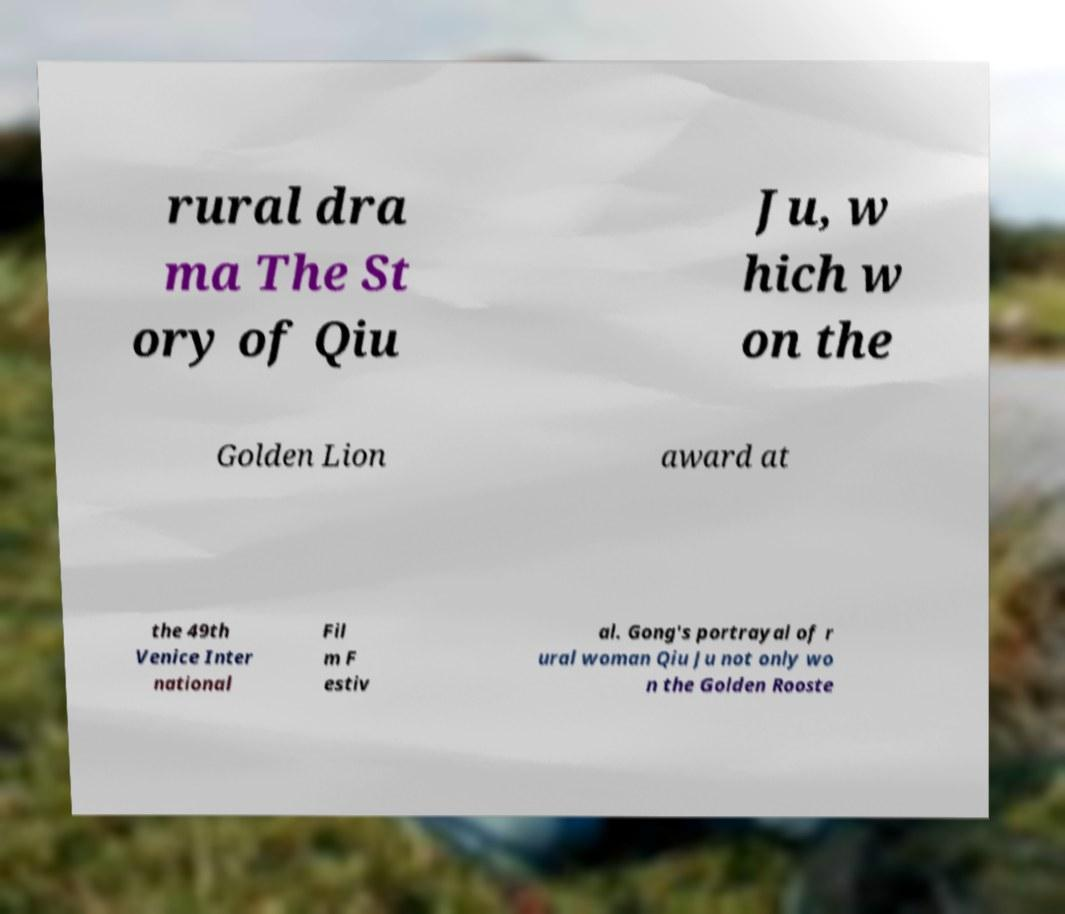What messages or text are displayed in this image? I need them in a readable, typed format. rural dra ma The St ory of Qiu Ju, w hich w on the Golden Lion award at the 49th Venice Inter national Fil m F estiv al. Gong's portrayal of r ural woman Qiu Ju not only wo n the Golden Rooste 